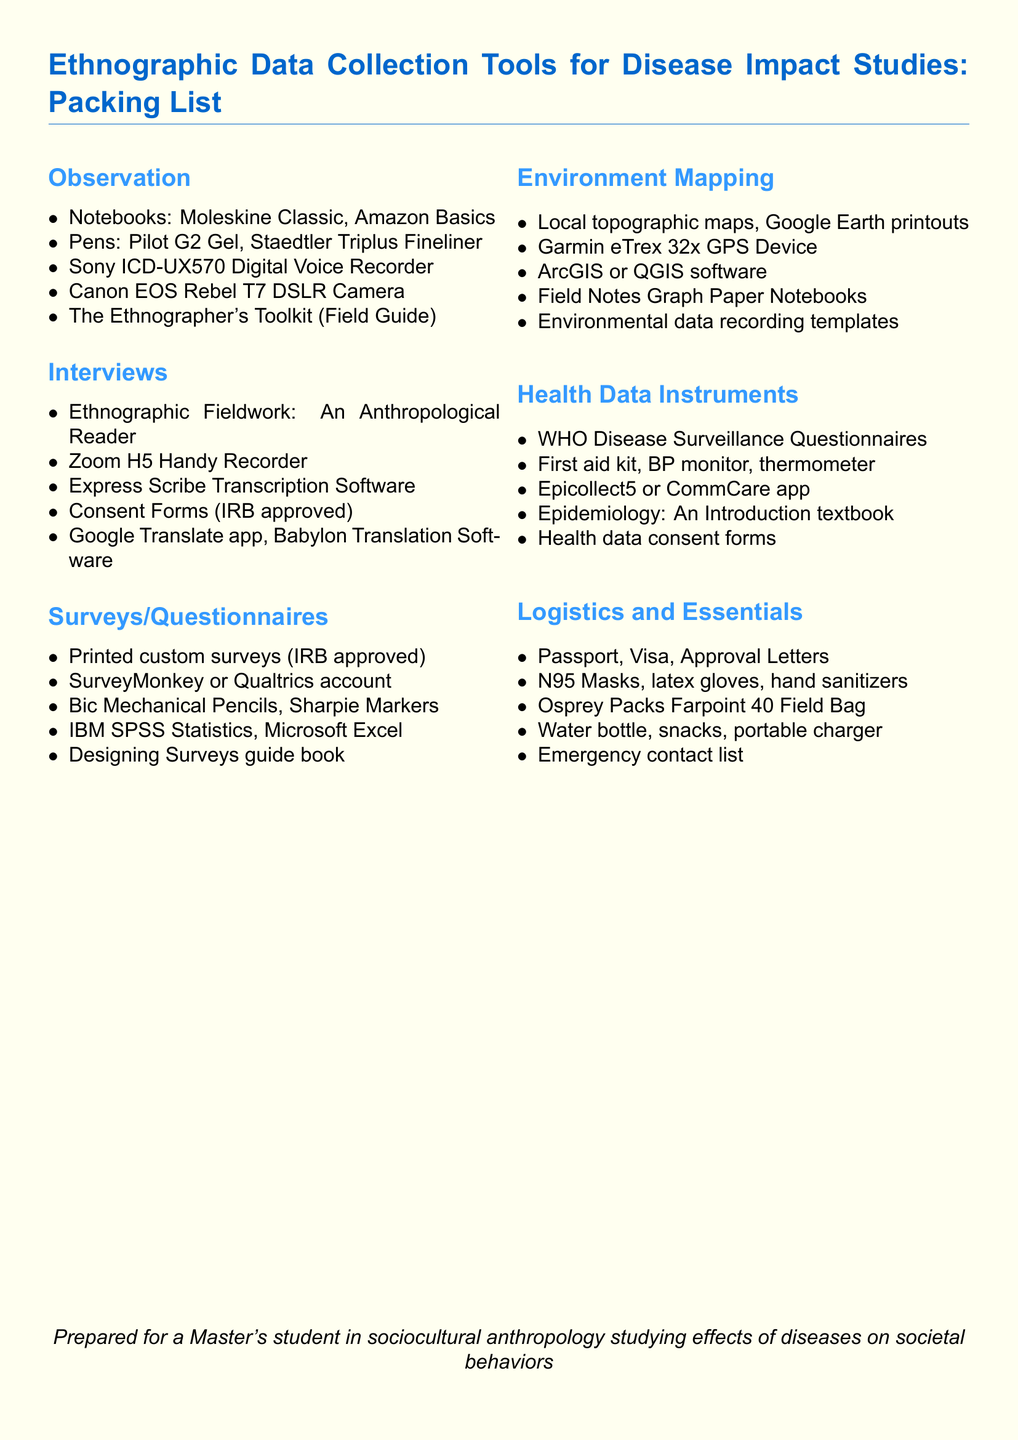what type of recorder is included in the observation section? The observation section lists the Sony ICD-UX570 Digital Voice Recorder as a tool for data collection.
Answer: Sony ICD-UX570 Digital Voice Recorder which software is mentioned for transcription in the interviews section? The interviews section specifies Express Scribe Transcription Software as a tool for transcription tasks.
Answer: Express Scribe Transcription Software what is one item listed under Health Data Instruments? The Health Data Instruments category includes tools relevant to health data gathering, one of which is the WHO Disease Surveillance Questionnaires.
Answer: WHO Disease Surveillance Questionnaires how many categories are listed in the packing list? The packing list organizes tools into six distinct categories for effective data collection.
Answer: 6 which GPS device is mentioned for environment mapping? The packing list includes the Garmin eTrex 32x GPS Device in the environment mapping category.
Answer: Garmin eTrex 32x GPS Device what type of maps are suggested for environment mapping? The packing list recommends using local topographic maps as part of the tools for environment mapping.
Answer: Local topographic maps what type of masks are included in the logistics and essentials section? The document specifies N95 Masks as part of the logistics and essentials tools required for fieldwork.
Answer: N95 Masks which statistical software is listed under surveys/questionnaires? The packing list under surveys/questionnaires includes IBM SPSS Statistics for analyzing survey data.
Answer: IBM SPSS Statistics which book is recommended for designing surveys? The document lists a guide book specifically for designing surveys in the context of data collection.
Answer: Designing Surveys guide book 